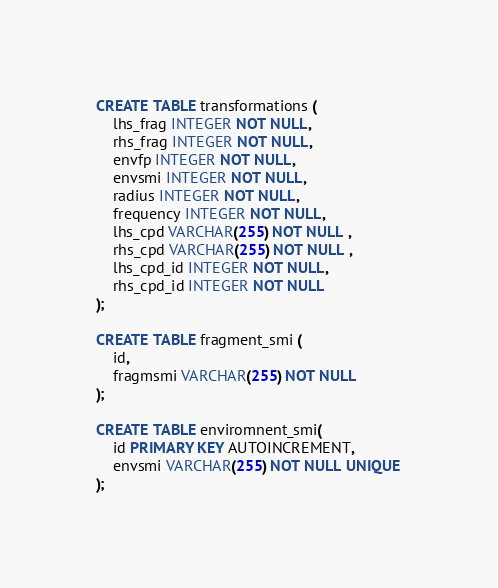Convert code to text. <code><loc_0><loc_0><loc_500><loc_500><_SQL_>CREATE TABLE transformations (
    lhs_frag INTEGER NOT NULL,
    rhs_frag INTEGER NOT NULL,
    envfp INTEGER NOT NULL,
    envsmi INTEGER NOT NULL,
    radius INTEGER NOT NULL,
    frequency INTEGER NOT NULL,
    lhs_cpd VARCHAR(255) NOT NULL ,
    rhs_cpd VARCHAR(255) NOT NULL ,
    lhs_cpd_id INTEGER NOT NULL,
    rhs_cpd_id INTEGER NOT NULL
);

CREATE TABLE fragment_smi (
    id,
    fragmsmi VARCHAR(255) NOT NULL 
);

CREATE TABLE enviromnent_smi(
    id PRIMARY KEY AUTOINCREMENT,
    envsmi VARCHAR(255) NOT NULL UNIQUE
);
</code> 